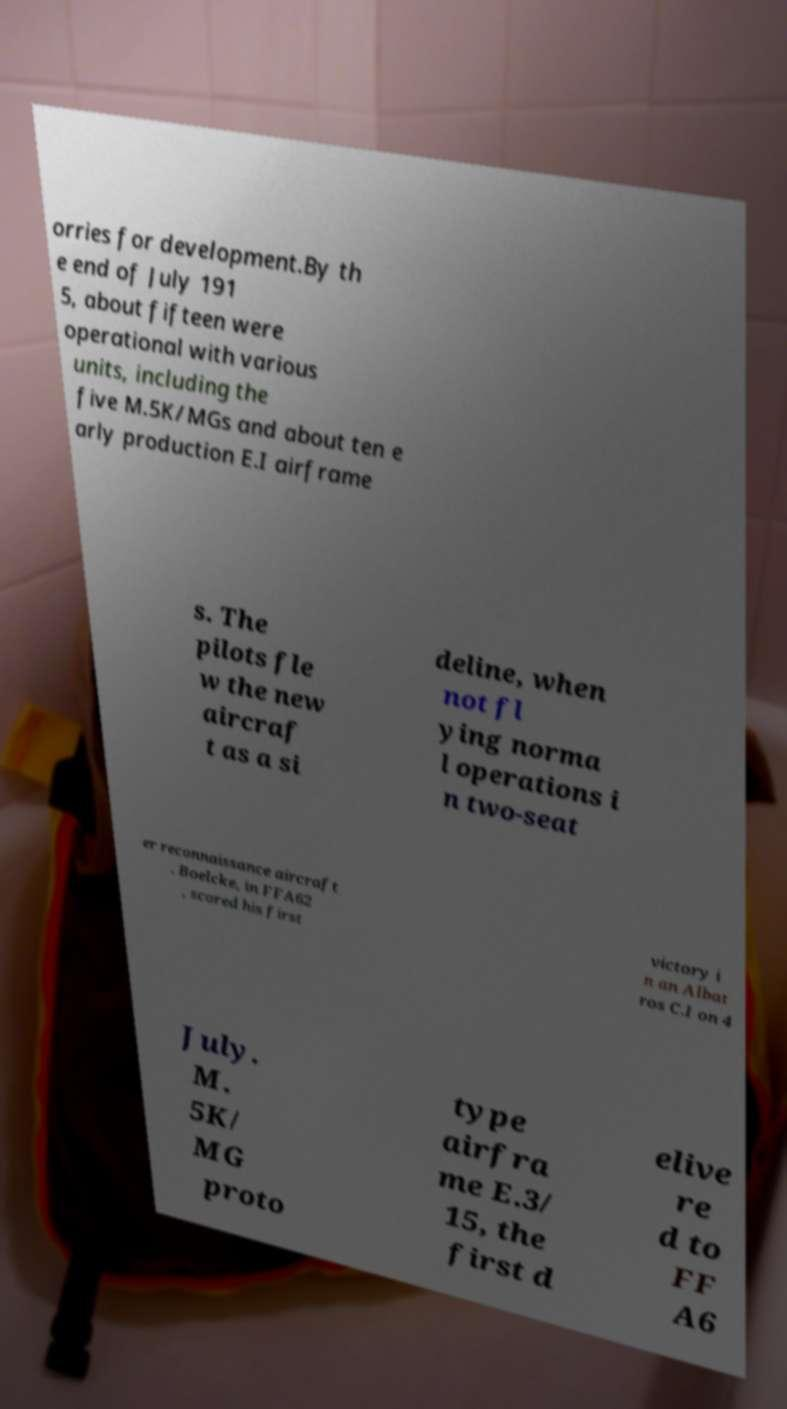Could you assist in decoding the text presented in this image and type it out clearly? orries for development.By th e end of July 191 5, about fifteen were operational with various units, including the five M.5K/MGs and about ten e arly production E.I airframe s. The pilots fle w the new aircraf t as a si deline, when not fl ying norma l operations i n two-seat er reconnaissance aircraft . Boelcke, in FFA62 , scored his first victory i n an Albat ros C.I on 4 July. M. 5K/ MG proto type airfra me E.3/ 15, the first d elive re d to FF A6 